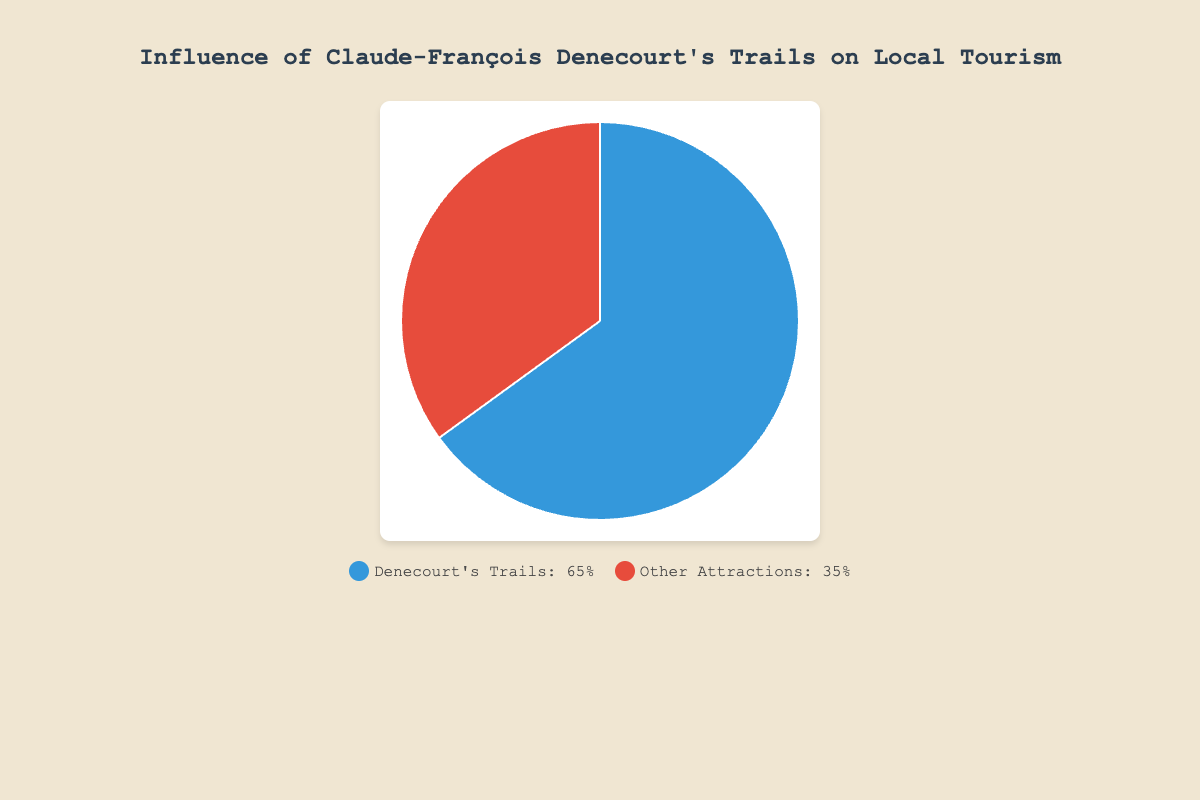Which category influences local tourism more? From the chart, Denecourt's Trails account for 65% while Other Attractions account for 35%. Since 65% is greater than 35%, Denecourt's Trails have a greater influence.
Answer: Denecourt's Trails What is the ratio of the influence of Denecourt's Trails to Other Attractions? The ratio is found by dividing the percentage of Denecourt's Trails by the percentage of Other Attractions. It is 65 / 35. Simplifying this, we get approximately 1.86.
Answer: 1.86 If the total tourism influence is represented by 100 votes, how many votes would be attributed to Denecourt's Trails? Denecourt's Trails influence 65% of tourism. Therefore, in 100 votes, 65% of 100 is 65 votes.
Answer: 65 How much more influence do Denecourt's Trails have compared to Other Attractions in percentage points? The influence of Denecourt's Trails is 65% while Other Attractions is 35%. The difference is 65% - 35% = 30 percentage points.
Answer: 30 percentage points In terms of visual color, how is the category of Denecourt's Trails represented? From the color legend, Denecourt's Trails are represented by blue. This matches the blue portion of the pie chart.
Answer: Blue What percentage of local tourism is influenced by attractions other than Denecourt's Trails? According to the chart, Other Attractions account for 35% of the local tourism influence.
Answer: 35% If the pie chart was split into quarters, would either category fill more than one quarter of the chart? A quarter of the pie chart is 25%. Denecourt's Trails account for 65%, which is more than one quarter. Other Attractions account for 35%, which is also more than one quarter.
Answer: Yes Estimate the difference in votes if the total number of votes for tourism influence is 1000 instead of 100. For Denecourt's Trails: 65% of 1000 is 650 votes. For Other Attractions: 35% of 1000 is 350 votes. The difference is 650 - 350 = 300 votes.
Answer: 300 votes Which category is represented by the color red in the pie chart? Referring to the legend, the color red corresponds to Other Attractions.
Answer: Other Attractions What fraction of the pie chart is occupied by Other Attractions? The pie chart has 100%, and Other Attractions occupy 35%, which is 35/100. Simplifying this, we get 7/20.
Answer: 7/20 